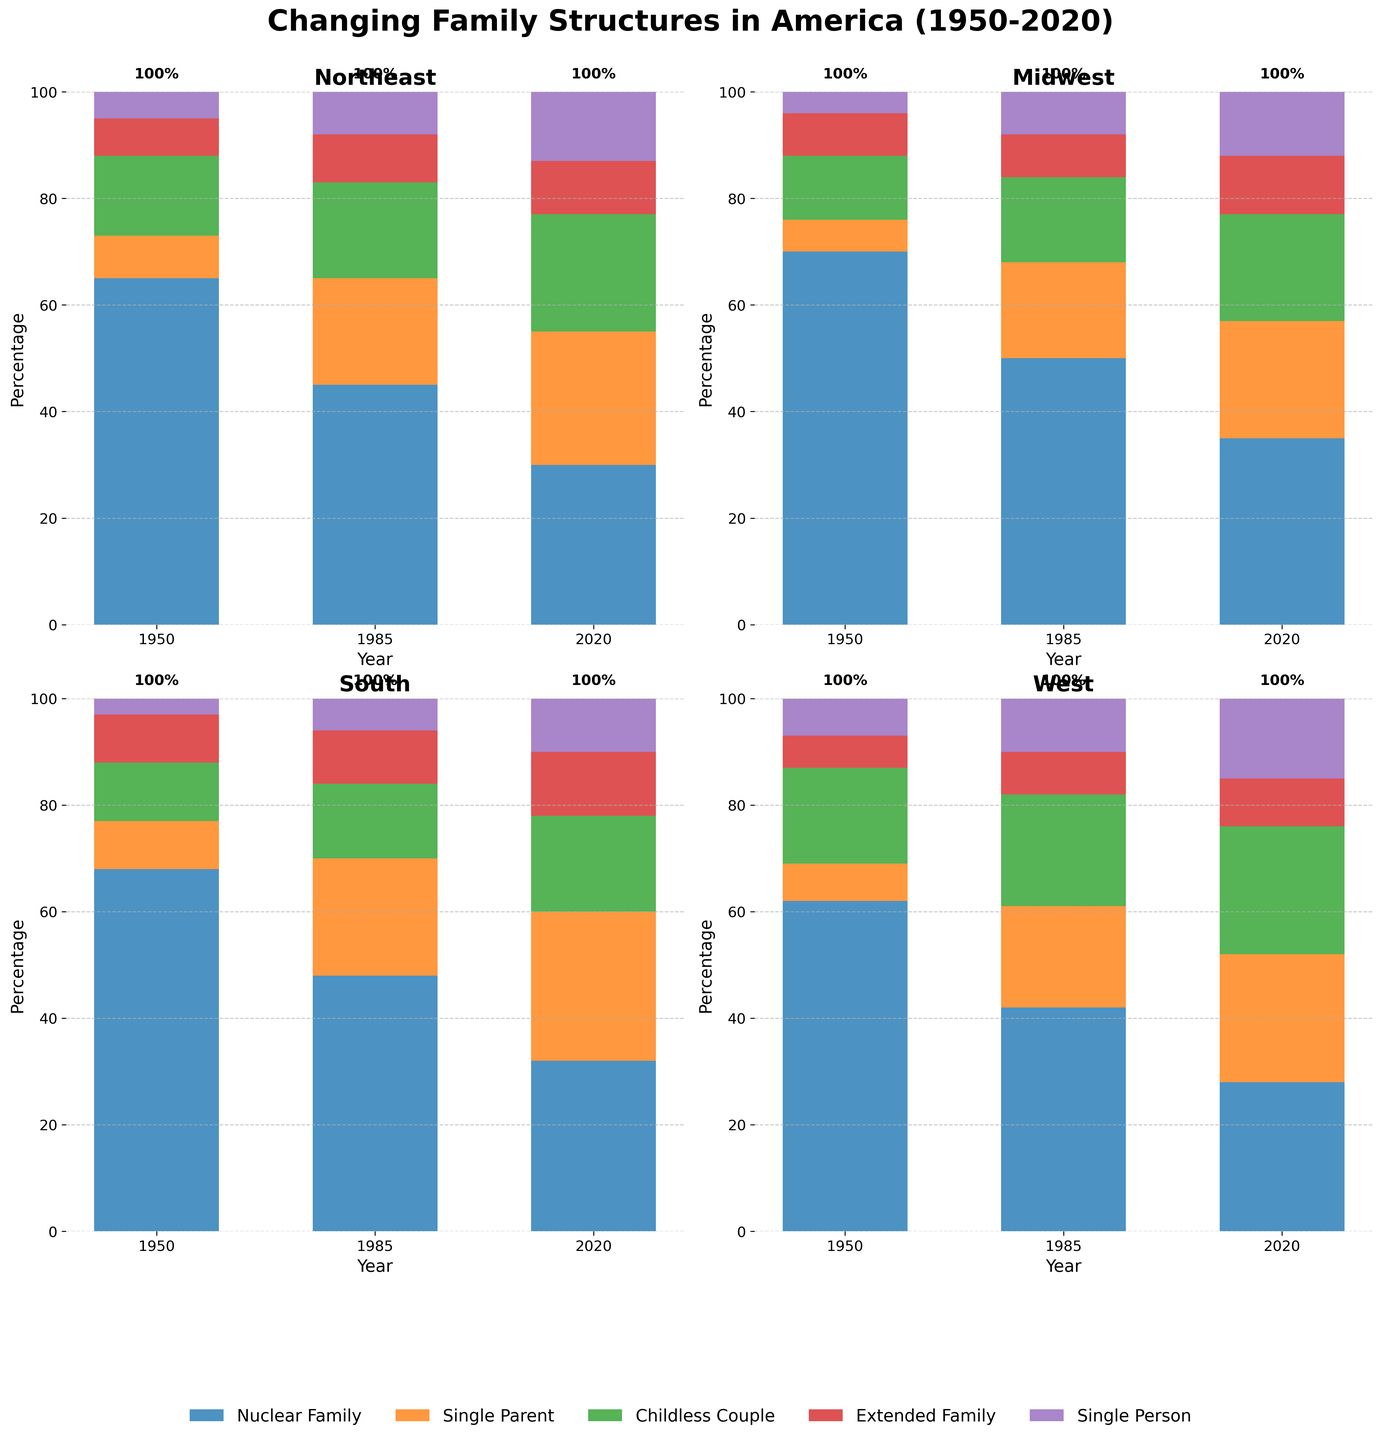What is the title of the plot? The title is found at the top of the figure. It provides a summary of what the plot represents.
Answer: Changing Family Structures in America (1950-2020) Which geographic region had the highest percentage of nuclear families in 1950? To find this, look at the height of the segments labeled "Nuclear Family" in the 1950 bar for each region.
Answer: Midwest How did the percentage of single-person households in the West change from 1950 to 2020? Locate the "Single Person" segments in the West for the years 1950 and 2020. Compare their heights.
Answer: Increased from 7% to 15% Which region showed the greatest increase in single-parent households from 1950 to 2020? Check the difference in the height of the "Single Parent" segments in 1950 and 2020 for each region. Compare these differences.
Answer: South Compare the percentage of childless couples in the South and the West in 2020. Which region has a higher percentage? Look at the height of the "Childless Couple" segments for the South and West in 2020. Compare the heights.
Answer: West In which year did the Northeast have the lowest percentage of nuclear families? Examine the "Nuclear Family" segments for the Northeast in each year presented and identify the lowest one.
Answer: 2020 What is the difference in the percentage of extended families in the Midwest between 1950 and 2020? Subtract the percentage of extended families in the Midwest in 1950 from their percentage in 2020.
Answer: 3% By how much did the percentage of single-parent households in the Northeast increase from 1985 to 2020? Subtract the percentage of single-parent households in the Northeast in 1985 from their percentage in 2020.
Answer: 5% What was the total percentage of households other than nuclear families in the South in 1985? Sum up the percentages of all non-nuclear family household types in the South in 1985: Single Parent, Childless Couple, Extended Family, and Single Person.
Answer: 52% Which region showed the least change in the percentage of nuclear families from 1950 to 2020? Calculate the difference in the nuclear families' percentage between 1950 and 2020 for each region. Identify the smallest difference.
Answer: Midwest 